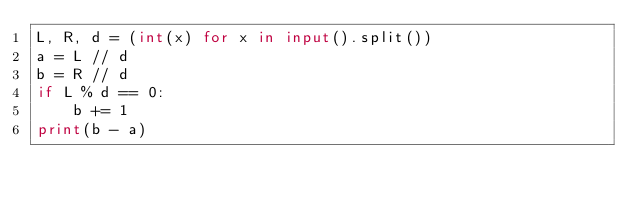<code> <loc_0><loc_0><loc_500><loc_500><_Python_>L, R, d = (int(x) for x in input().split())
a = L // d
b = R // d
if L % d == 0:
    b += 1
print(b - a)
</code> 